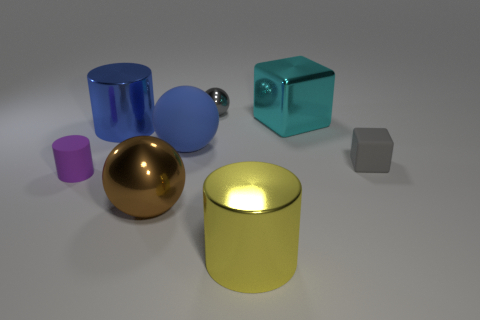Add 1 large blue objects. How many objects exist? 9 Subtract all blocks. How many objects are left? 6 Subtract all large gray cylinders. Subtract all metal spheres. How many objects are left? 6 Add 8 metallic spheres. How many metallic spheres are left? 10 Add 7 tiny yellow rubber spheres. How many tiny yellow rubber spheres exist? 7 Subtract 0 brown cylinders. How many objects are left? 8 